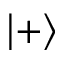<formula> <loc_0><loc_0><loc_500><loc_500>\left | + \right ></formula> 